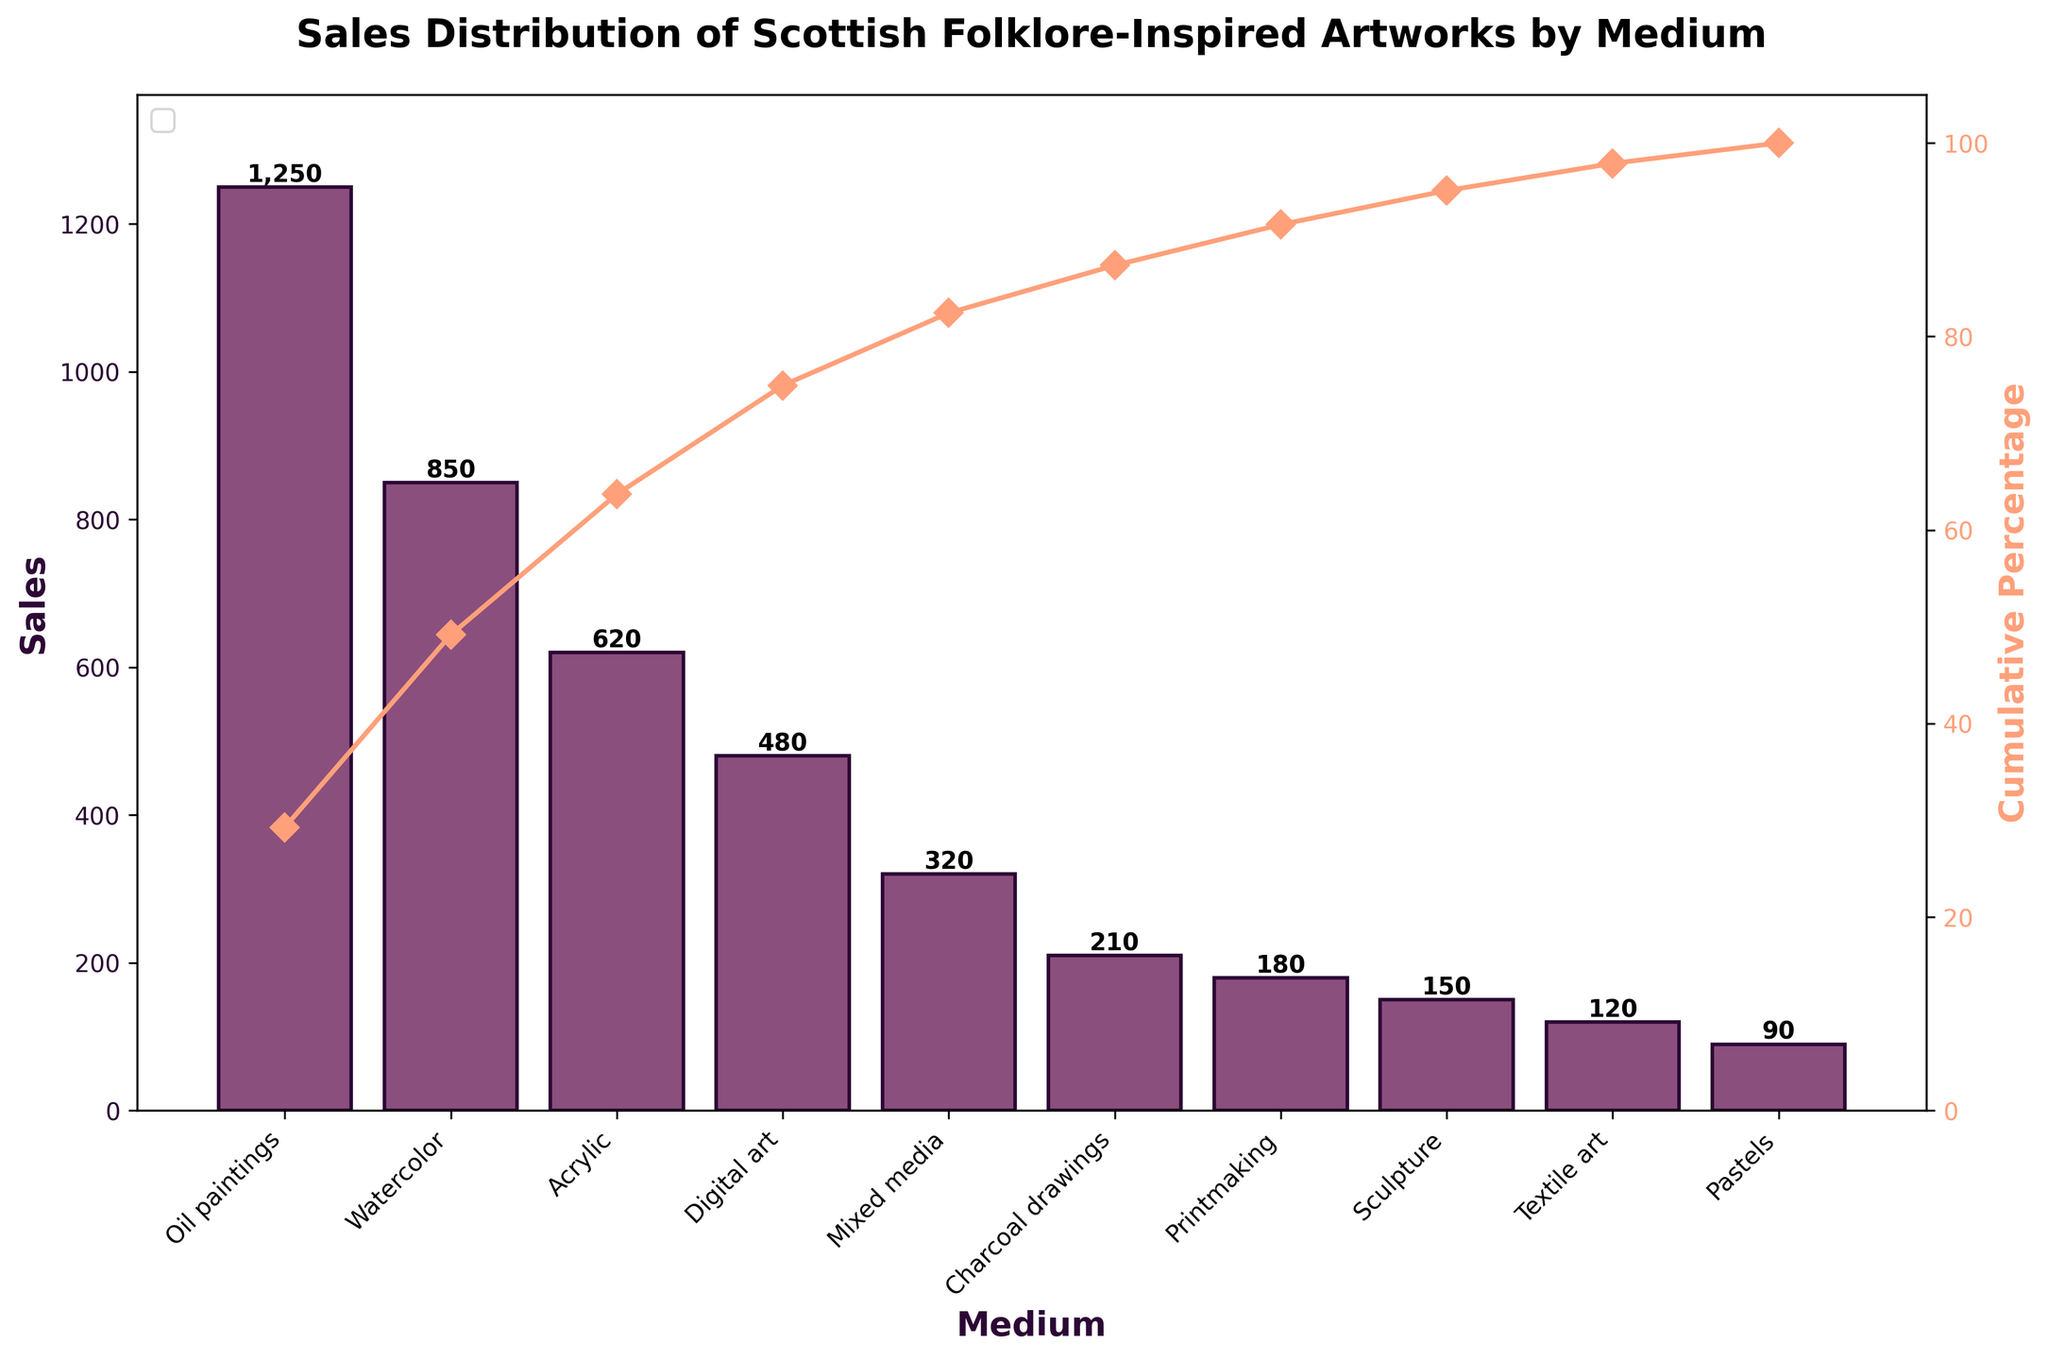What's the title of the figure? The title of the figure is visually prominent at the top of the Pareto chart. Titles are generally meant to summarize what the figure is about in a concise manner, often set in a larger and bold font.
Answer: Sales Distribution of Scottish Folklore-Inspired Artworks by Medium How many mediums are displayed in the figure? The number of mediums can be counted from the bars that are present on the x-axis of the chart. Each bar represents one medium.
Answer: 10 Which medium has the highest sales? The medium with the highest sales will have the tallest bar in the Pareto chart. This is easily visible as the most prominent bar in the chart.
Answer: Oil paintings What is the sum of sales for the three least selling mediums? Identify the three shortest bars on the Pareto chart which represent the least selling mediums, then sum their sales values. The three least selling mediums are Textile art, Pastels, and Sculpture, with sales values of 120, 90, and 150, respectively. Summing these values gives 120 + 90 + 150 = 360.
Answer: 360 What is the difference in sales between Acrylic and Digital art? Locate the bars for Acrylic and Digital art, then subtract the smaller sales value (Digital art: 480) from the larger sales value (Acrylic: 620). The difference is 620 - 480 = 140.
Answer: 140 Which medium crosses the 50% cumulative percentage mark? To determine the medium crossing the 50% mark, note the point at which the cumulative percentage line intersects 50% on the secondary y-axis. Observing this, we see Watercolor reaches slightly above the 50% mark.
Answer: Watercolor What portion of total sales do Oil paintings and Watercolor together constitute? Add the sales values for Oil paintings (1250) and Watercolor (850) to get the combined sales, which is 1250 + 850 = 2100. Calculate the total sales of all mediums, which is the sum of all bars' heights, totaling 4270. The portion is then (2100 / 4270) * 100, approximately 49.2%.
Answer: Approximately 49.2% How does the cumulative percentage change from Watercolor to Acrylic? First, find the cumulative percentage at Watercolor, then at Acrylic. The cumulative percentage at Watercolor is around 50%, and at Acrylic is approximately 75%. The change is found by subtracting these values: 75% - 50% = 25%.
Answer: 25% Does the cumulative percentage line reach 100% by the last medium? Examine the cumulative percentage line at the end of the x-axis. The line should ideally reach or be very close to 100% as it accounts for the cumulative sum of all sales. The cumulative percentage line at Pastels reaches around 100%.
Answer: Yes 